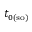<formula> <loc_0><loc_0><loc_500><loc_500>t _ { 0 ( s o ) }</formula> 